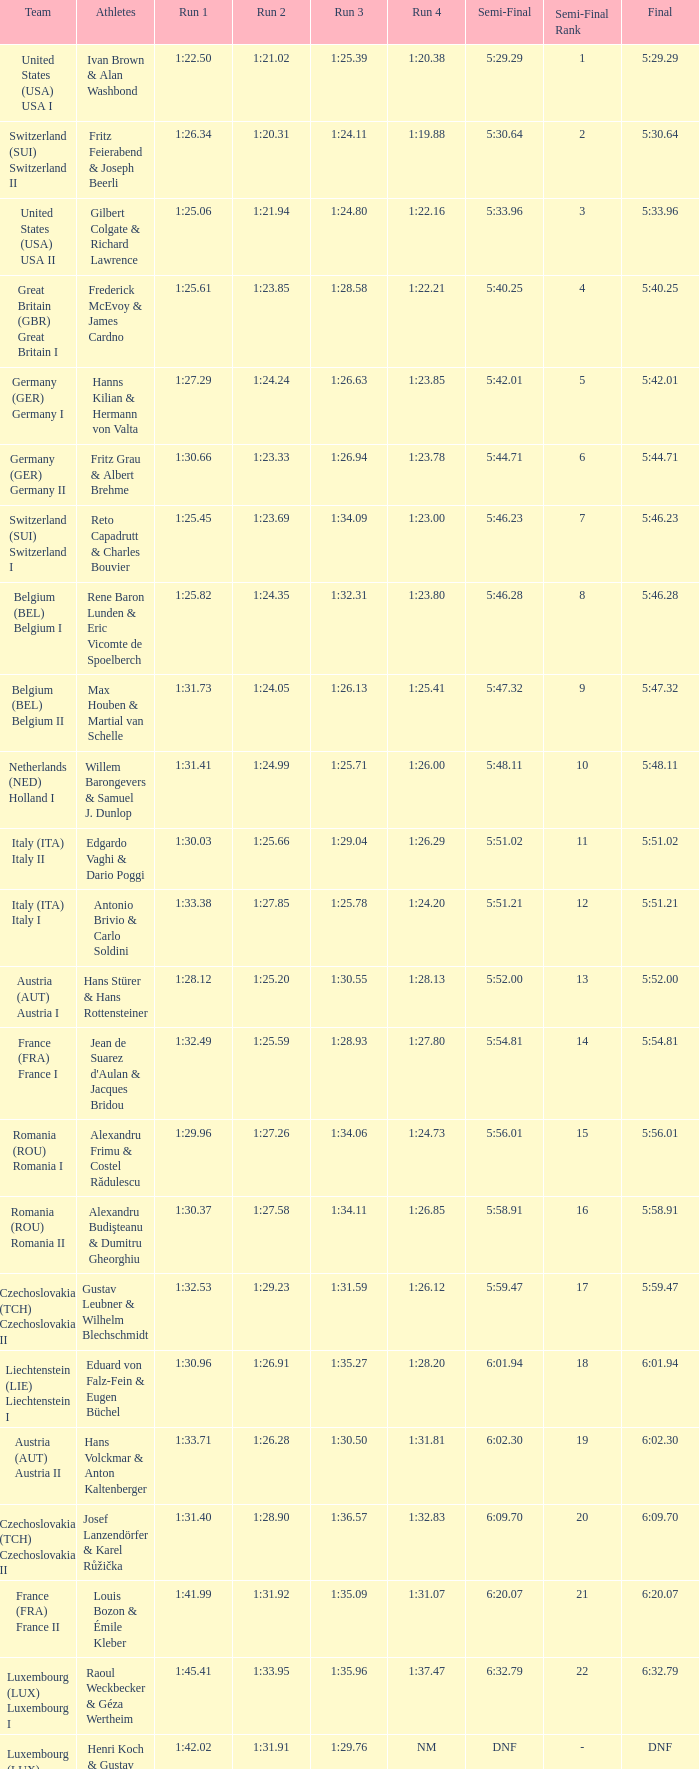Which Run 2 has a Run 1 of 1:30.03? 1:25.66. Could you parse the entire table as a dict? {'header': ['Team', 'Athletes', 'Run 1', 'Run 2', 'Run 3', 'Run 4', 'Semi-Final', 'Semi-Final Rank', 'Final'], 'rows': [['United States (USA) USA I', 'Ivan Brown & Alan Washbond', '1:22.50', '1:21.02', '1:25.39', '1:20.38', '5:29.29', '1', '5:29.29'], ['Switzerland (SUI) Switzerland II', 'Fritz Feierabend & Joseph Beerli', '1:26.34', '1:20.31', '1:24.11', '1:19.88', '5:30.64', '2', '5:30.64'], ['United States (USA) USA II', 'Gilbert Colgate & Richard Lawrence', '1:25.06', '1:21.94', '1:24.80', '1:22.16', '5:33.96', '3', '5:33.96'], ['Great Britain (GBR) Great Britain I', 'Frederick McEvoy & James Cardno', '1:25.61', '1:23.85', '1:28.58', '1:22.21', '5:40.25', '4', '5:40.25'], ['Germany (GER) Germany I', 'Hanns Kilian & Hermann von Valta', '1:27.29', '1:24.24', '1:26.63', '1:23.85', '5:42.01', '5', '5:42.01'], ['Germany (GER) Germany II', 'Fritz Grau & Albert Brehme', '1:30.66', '1:23.33', '1:26.94', '1:23.78', '5:44.71', '6', '5:44.71'], ['Switzerland (SUI) Switzerland I', 'Reto Capadrutt & Charles Bouvier', '1:25.45', '1:23.69', '1:34.09', '1:23.00', '5:46.23', '7', '5:46.23'], ['Belgium (BEL) Belgium I', 'Rene Baron Lunden & Eric Vicomte de Spoelberch', '1:25.82', '1:24.35', '1:32.31', '1:23.80', '5:46.28', '8', '5:46.28'], ['Belgium (BEL) Belgium II', 'Max Houben & Martial van Schelle', '1:31.73', '1:24.05', '1:26.13', '1:25.41', '5:47.32', '9', '5:47.32'], ['Netherlands (NED) Holland I', 'Willem Barongevers & Samuel J. Dunlop', '1:31.41', '1:24.99', '1:25.71', '1:26.00', '5:48.11', '10', '5:48.11'], ['Italy (ITA) Italy II', 'Edgardo Vaghi & Dario Poggi', '1:30.03', '1:25.66', '1:29.04', '1:26.29', '5:51.02', '11', '5:51.02'], ['Italy (ITA) Italy I', 'Antonio Brivio & Carlo Soldini', '1:33.38', '1:27.85', '1:25.78', '1:24.20', '5:51.21', '12', '5:51.21'], ['Austria (AUT) Austria I', 'Hans Stürer & Hans Rottensteiner', '1:28.12', '1:25.20', '1:30.55', '1:28.13', '5:52.00', '13', '5:52.00'], ['France (FRA) France I', "Jean de Suarez d'Aulan & Jacques Bridou", '1:32.49', '1:25.59', '1:28.93', '1:27.80', '5:54.81', '14', '5:54.81'], ['Romania (ROU) Romania I', 'Alexandru Frimu & Costel Rădulescu', '1:29.96', '1:27.26', '1:34.06', '1:24.73', '5:56.01', '15', '5:56.01'], ['Romania (ROU) Romania II', 'Alexandru Budişteanu & Dumitru Gheorghiu', '1:30.37', '1:27.58', '1:34.11', '1:26.85', '5:58.91', '16', '5:58.91'], ['Czechoslovakia (TCH) Czechoslovakia II', 'Gustav Leubner & Wilhelm Blechschmidt', '1:32.53', '1:29.23', '1:31.59', '1:26.12', '5:59.47', '17', '5:59.47'], ['Liechtenstein (LIE) Liechtenstein I', 'Eduard von Falz-Fein & Eugen Büchel', '1:30.96', '1:26.91', '1:35.27', '1:28.20', '6:01.94', '18', '6:01.94'], ['Austria (AUT) Austria II', 'Hans Volckmar & Anton Kaltenberger', '1:33.71', '1:26.28', '1:30.50', '1:31.81', '6:02.30', '19', '6:02.30'], ['Czechoslovakia (TCH) Czechoslovakia II', 'Josef Lanzendörfer & Karel Růžička', '1:31.40', '1:28.90', '1:36.57', '1:32.83', '6:09.70', '20', '6:09.70'], ['France (FRA) France II', 'Louis Bozon & Émile Kleber', '1:41.99', '1:31.92', '1:35.09', '1:31.07', '6:20.07', '21', '6:20.07'], ['Luxembourg (LUX) Luxembourg I', 'Raoul Weckbecker & Géza Wertheim', '1:45.41', '1:33.95', '1:35.96', '1:37.47', '6:32.79', '22', '6:32.79'], ['Luxembourg (LUX) Luxembourg II', 'Henri Koch & Gustav Wagner', '1:42.02', '1:31.91', '1:29.76', 'NM', 'DNF', '-', 'DNF']]} 